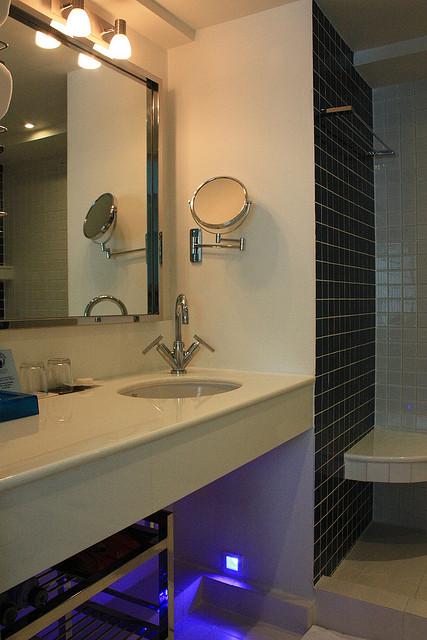What shape is the mirror?
Short answer required. Rectangle. What room is this?
Write a very short answer. Bathroom. How many faucets are there?
Answer briefly. 1. What type of room is this?
Be succinct. Bathroom. Where is the scene in the picture?
Concise answer only. Bathroom. What color is the tile?
Quick response, please. Black. How many mirrors are shown?
Answer briefly. 2. 